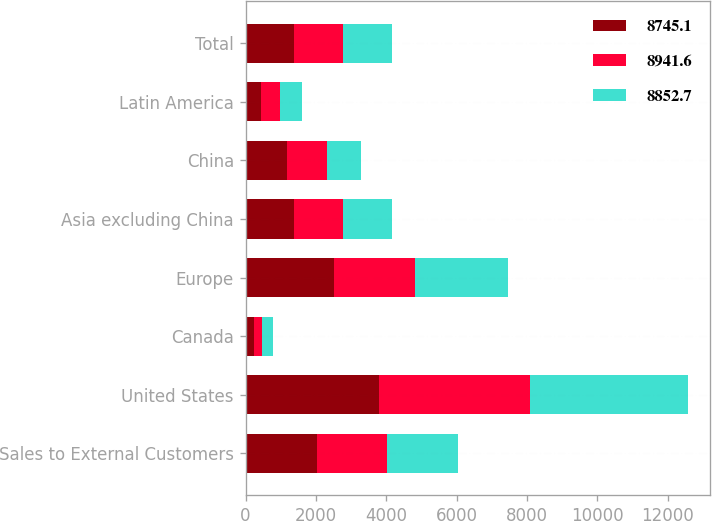<chart> <loc_0><loc_0><loc_500><loc_500><stacked_bar_chart><ecel><fcel>Sales to External Customers<fcel>United States<fcel>Canada<fcel>Europe<fcel>Asia excluding China<fcel>China<fcel>Latin America<fcel>Total<nl><fcel>8745.1<fcel>2016<fcel>3792.3<fcel>225.7<fcel>2505.9<fcel>1382.7<fcel>1176.2<fcel>441.6<fcel>1389.4<nl><fcel>8941.6<fcel>2015<fcel>4280.1<fcel>247.1<fcel>2315.4<fcel>1395.2<fcel>1129.1<fcel>528<fcel>1389.4<nl><fcel>8852.7<fcel>2014<fcel>4507.6<fcel>311.4<fcel>2628<fcel>1389.4<fcel>981<fcel>621.6<fcel>1389.4<nl></chart> 